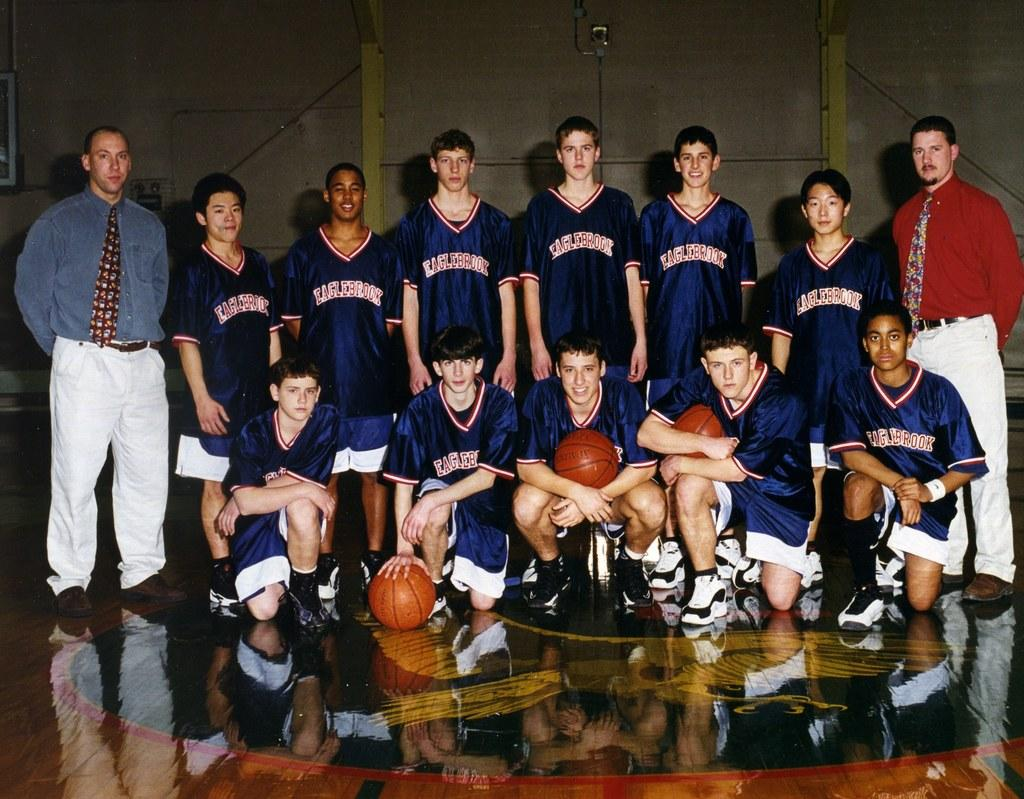<image>
Give a short and clear explanation of the subsequent image. a few people that are wearing Eaglebrook jerseys 